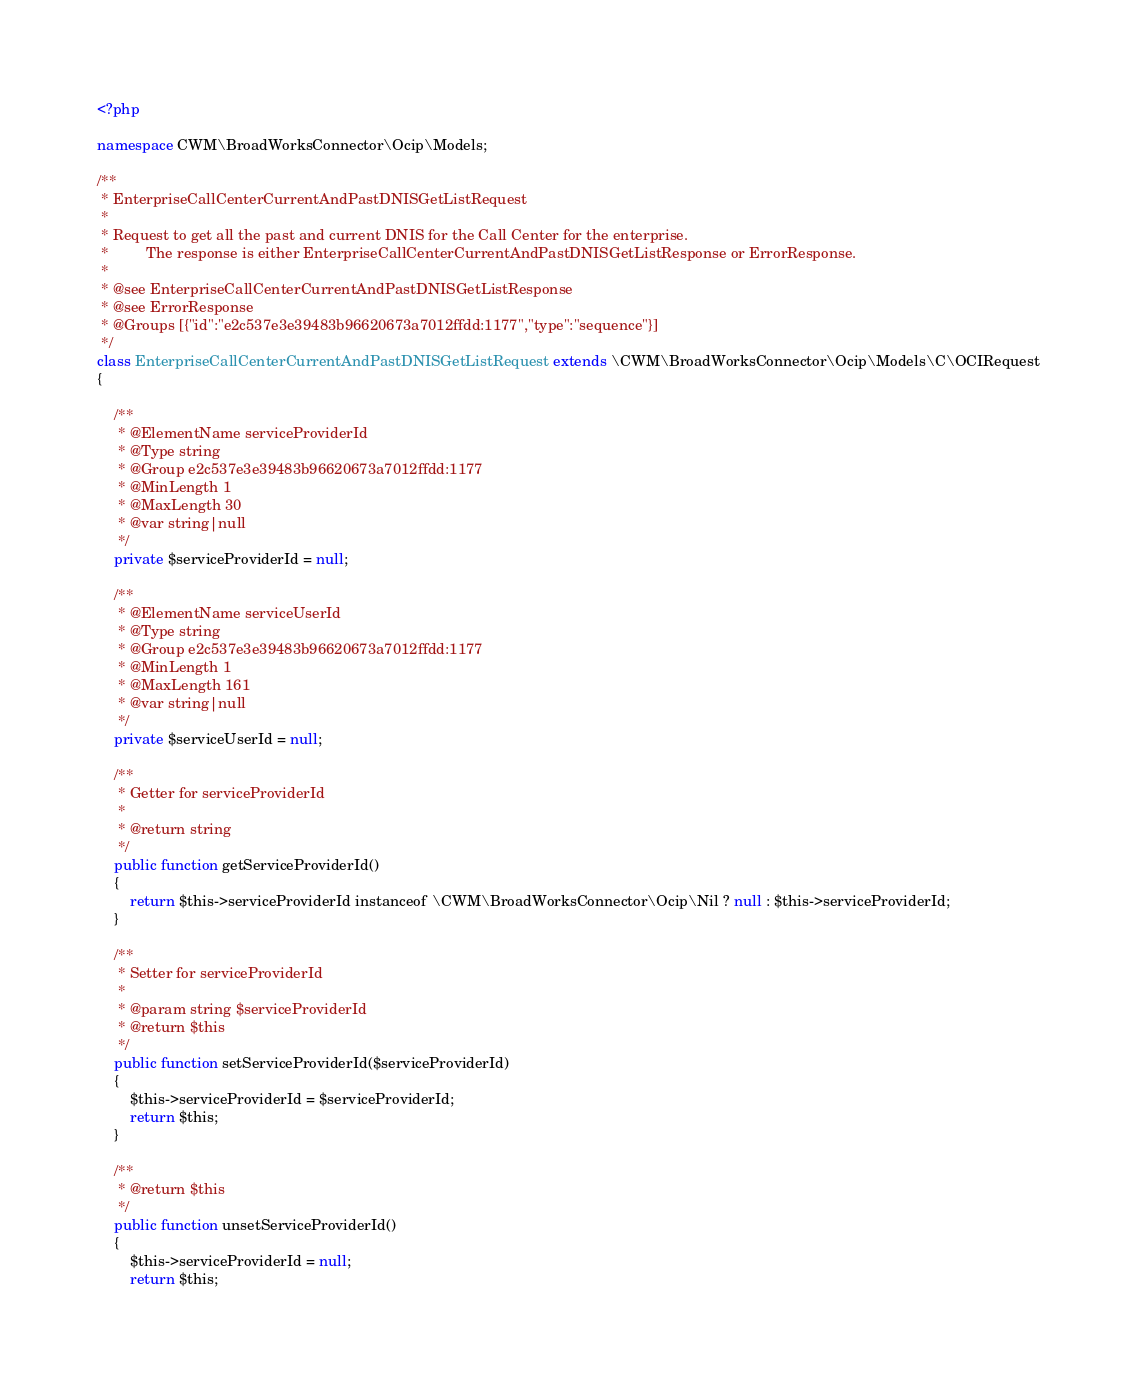Convert code to text. <code><loc_0><loc_0><loc_500><loc_500><_PHP_><?php

namespace CWM\BroadWorksConnector\Ocip\Models;

/**
 * EnterpriseCallCenterCurrentAndPastDNISGetListRequest
 *
 * Request to get all the past and current DNIS for the Call Center for the enterprise.
 *         The response is either EnterpriseCallCenterCurrentAndPastDNISGetListResponse or ErrorResponse.
 *
 * @see EnterpriseCallCenterCurrentAndPastDNISGetListResponse
 * @see ErrorResponse
 * @Groups [{"id":"e2c537e3e39483b96620673a7012ffdd:1177","type":"sequence"}]
 */
class EnterpriseCallCenterCurrentAndPastDNISGetListRequest extends \CWM\BroadWorksConnector\Ocip\Models\C\OCIRequest
{

    /**
     * @ElementName serviceProviderId
     * @Type string
     * @Group e2c537e3e39483b96620673a7012ffdd:1177
     * @MinLength 1
     * @MaxLength 30
     * @var string|null
     */
    private $serviceProviderId = null;

    /**
     * @ElementName serviceUserId
     * @Type string
     * @Group e2c537e3e39483b96620673a7012ffdd:1177
     * @MinLength 1
     * @MaxLength 161
     * @var string|null
     */
    private $serviceUserId = null;

    /**
     * Getter for serviceProviderId
     *
     * @return string
     */
    public function getServiceProviderId()
    {
        return $this->serviceProviderId instanceof \CWM\BroadWorksConnector\Ocip\Nil ? null : $this->serviceProviderId;
    }

    /**
     * Setter for serviceProviderId
     *
     * @param string $serviceProviderId
     * @return $this
     */
    public function setServiceProviderId($serviceProviderId)
    {
        $this->serviceProviderId = $serviceProviderId;
        return $this;
    }

    /**
     * @return $this
     */
    public function unsetServiceProviderId()
    {
        $this->serviceProviderId = null;
        return $this;</code> 